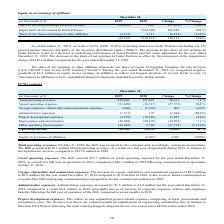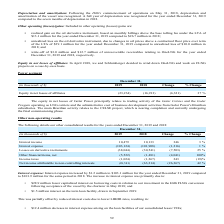According to Golar Lng's financial document, How much unrecoverable receivables was written off in 2018 relating to OneLNG? According to the financial document, $12.7 million. The relevant text states: "llion in 2018; and • write-off of $3.0 million and $12.7 million of unrecoverable receivables relating to OneLNG for the year ended December 31, 2019 and 2018, respe..." Also, How many months of depreciation was recognized in 2018? According to the financial document, Seven months. The relevant text states: "full year of operation of the Hilli , compared to seven months in 2018...." Also, What are the different components of expenses? The document contains multiple relevant values: Vessel operating expenses, Voyage expenses, charter-hire and commission expenses, Administrative expenses, Project development expenses, Depreciation and amortization, Other operating (losses)/gains. From the document: "and amortization (48,088) (28,193) (19,895) 71 % Other operating (losses)/gains (28,963) 2,749 (31,712) (1,154)% Operating income 82,586 58,150 24,436..." Additionally, In which year has a higher project development expense? According to the financial document, 2018. The relevant text states: "December 31, (in thousands of $) 2019 2018 Change % Change Share in net (loss)/earnings in Golar Partners (20,050) 7,001 (27,051) (386)% Impai..." Also, can you calculate: What was the change in total operating revenues? Based on the calculation: 218,096 - 127,625 , the result is 90471 (in thousands). This is based on the information: "Change % Change Total operating revenues 218,096 127,625 90,471 71 % Vessel operating expenses (53,689) (26,317) (27,372) 104 % Voyage expenses, charter-hir 019 2018 Change % Change Total operating re..." The key data points involved are: 127,625, 218,096. Also, can you calculate: What was the percentage change in operating income? To answer this question, I need to perform calculations using the financial data. The calculation is: (82,586 - 58,150)/58,150 , which equals 42.02 (percentage). This is based on the information: ") 2,749 (31,712) (1,154)% Operating income 82,586 58,150 24,436 42 % (28,963) 2,749 (31,712) (1,154)% Operating income 82,586 58,150 24,436 42 %..." The key data points involved are: 58,150, 82,586. 